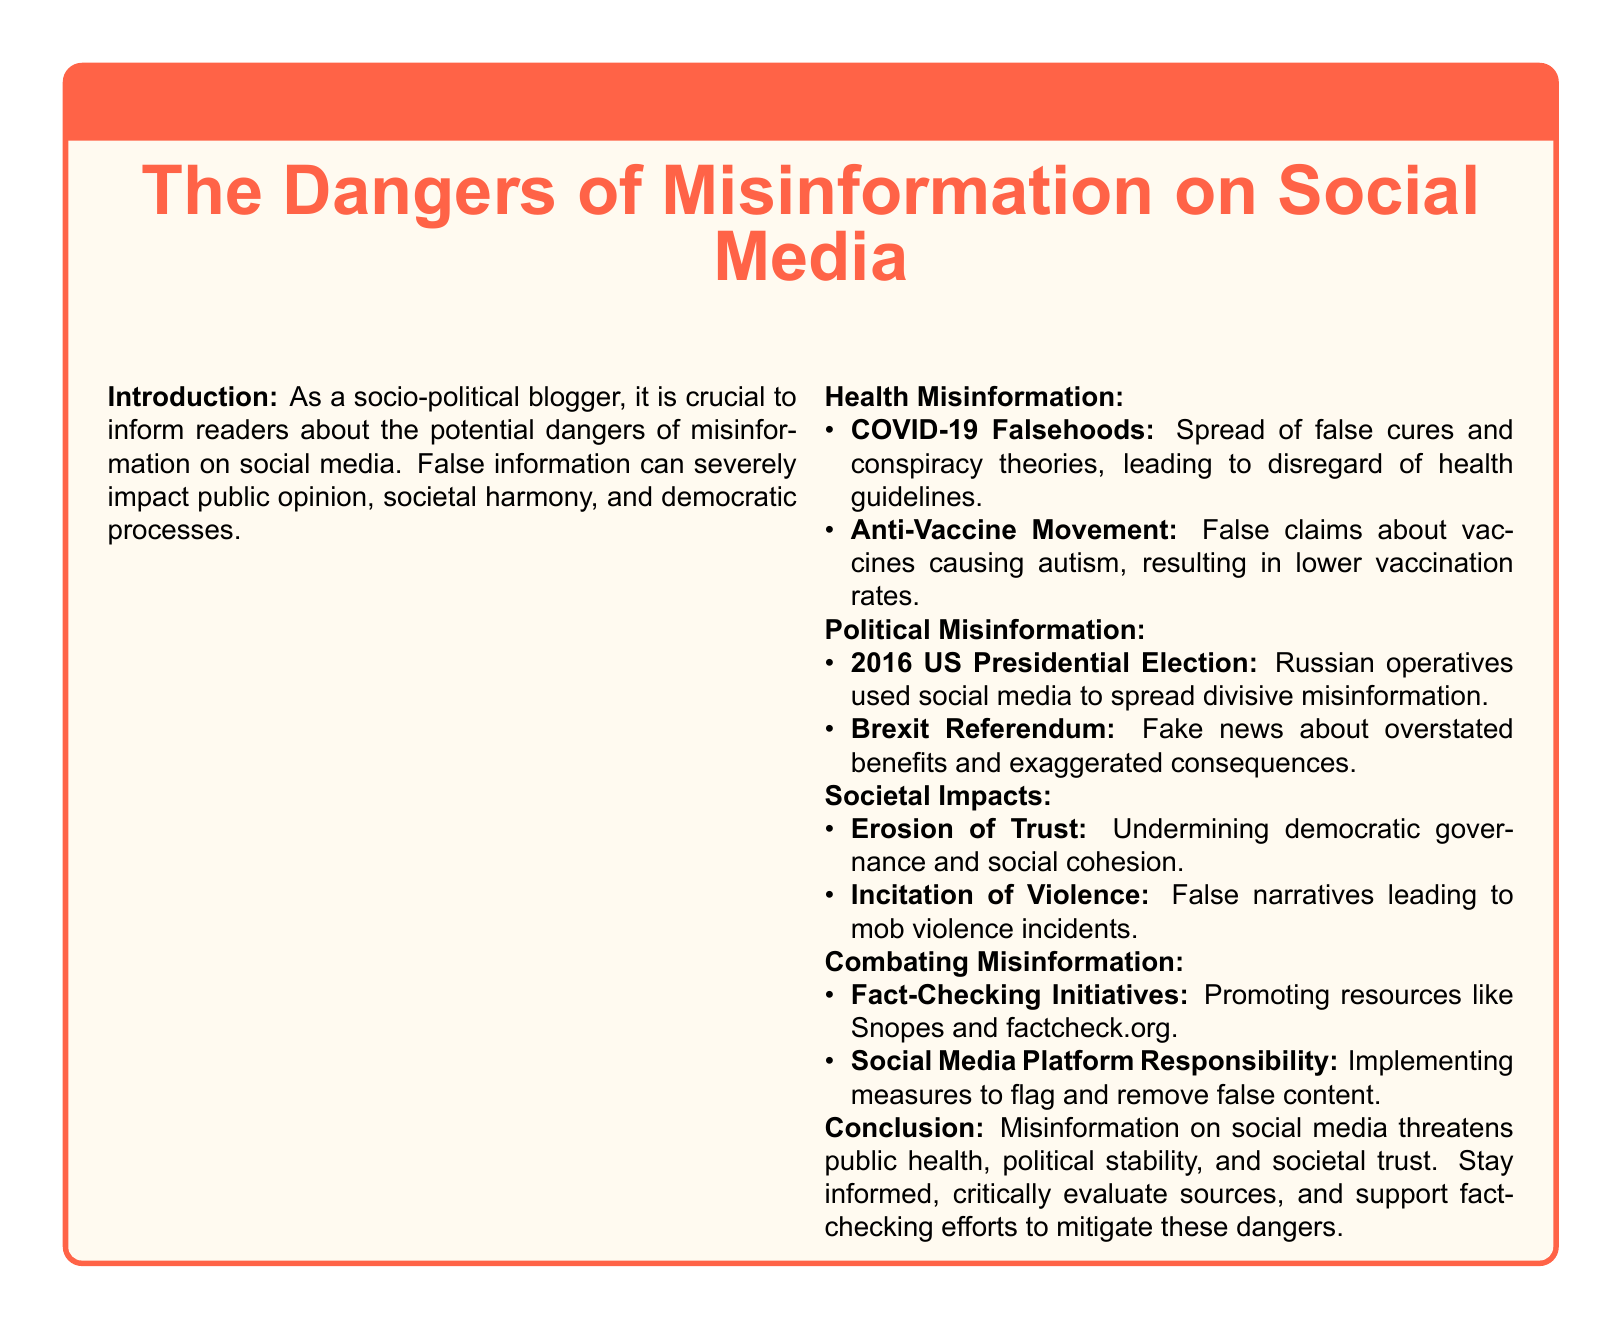What is the main topic of the warning label? The main topic is about the dangers of misinformation on social media.
Answer: The dangers of misinformation on social media What are two examples of health misinformation mentioned? The document lists COVID-19 falsehoods and the Anti-Vaccine Movement as examples.
Answer: COVID-19 Falsehoods, Anti-Vaccine Movement In which election was misinformation used by Russian operatives? The document specifies the 2016 US Presidential Election as the event in question.
Answer: 2016 US Presidential Election What societal impact is associated with the erosion of trust? The erosion of trust undermines democratic governance and social cohesion.
Answer: Democratic governance and social cohesion What are the two types of misinformation highlighted in the document? The document identifies health misinformation and political misinformation as two types.
Answer: Health misinformation, political misinformation What initiative is suggested to combat misinformation? The document promotes fact-checking initiatives like resources such as Snopes and factcheck.org.
Answer: Fact-Checking Initiatives What is the potential consequence of false narratives mentioned in the societal impacts? False narratives can lead to mob violence incidents as per the document.
Answer: Mob violence incidents What should individuals do to mitigate the dangers of misinformation? The document advises individuals to stay informed and critically evaluate sources.
Answer: Stay informed, critically evaluate sources 